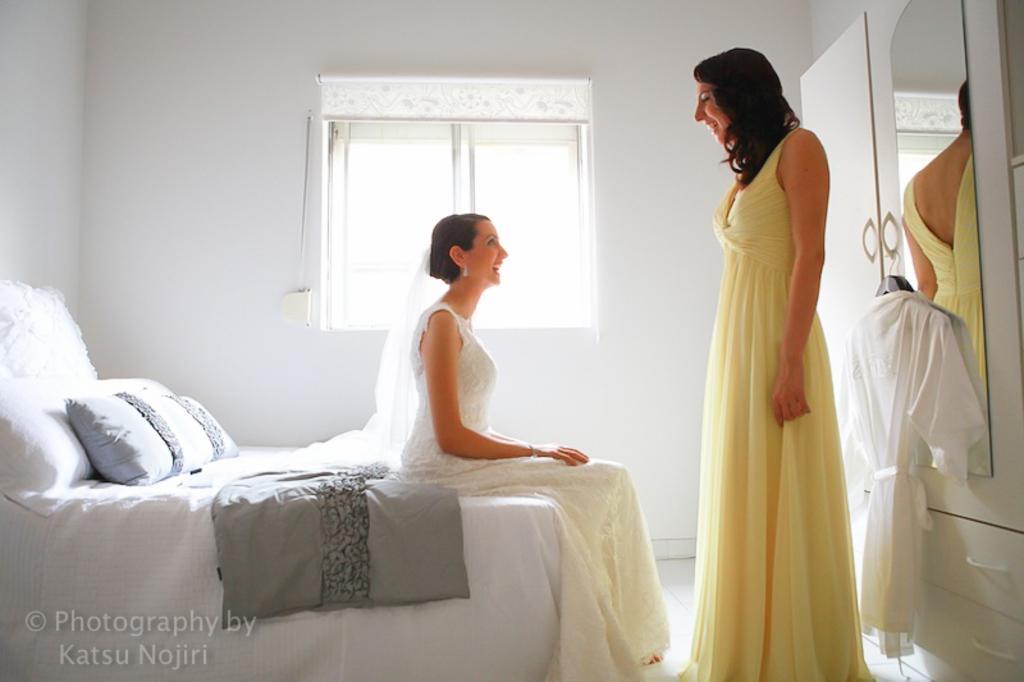Could you give a brief overview of what you see in this image? This picture is clicked inside the room and in middle, we see women woman wearing white dress is sitting on the bed and she is laughing. Beside her, we see woman in white yellow dress is standing and laughing. Beside her, we see mirror which is fitted to a white color cupboard. We see pillow and blanket on the blood on the bed and behind this, we see a wall which is white in color and next to it we see window. 